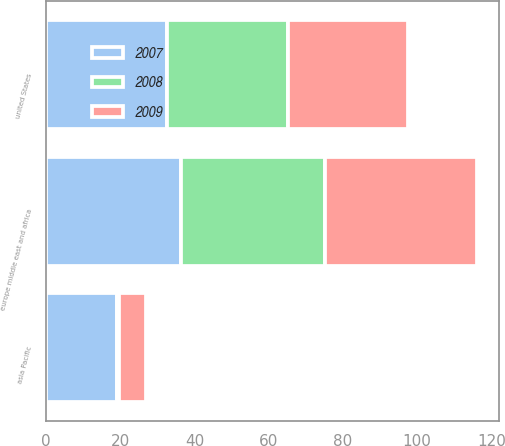Convert chart to OTSL. <chart><loc_0><loc_0><loc_500><loc_500><stacked_bar_chart><ecel><fcel>united States<fcel>europe middle east and africa<fcel>asia Pacific<nl><fcel>2007<fcel>32.6<fcel>36.4<fcel>19<nl><fcel>2008<fcel>32.55<fcel>38.7<fcel>0.7<nl><fcel>2009<fcel>32.5<fcel>41.1<fcel>7.2<nl></chart> 